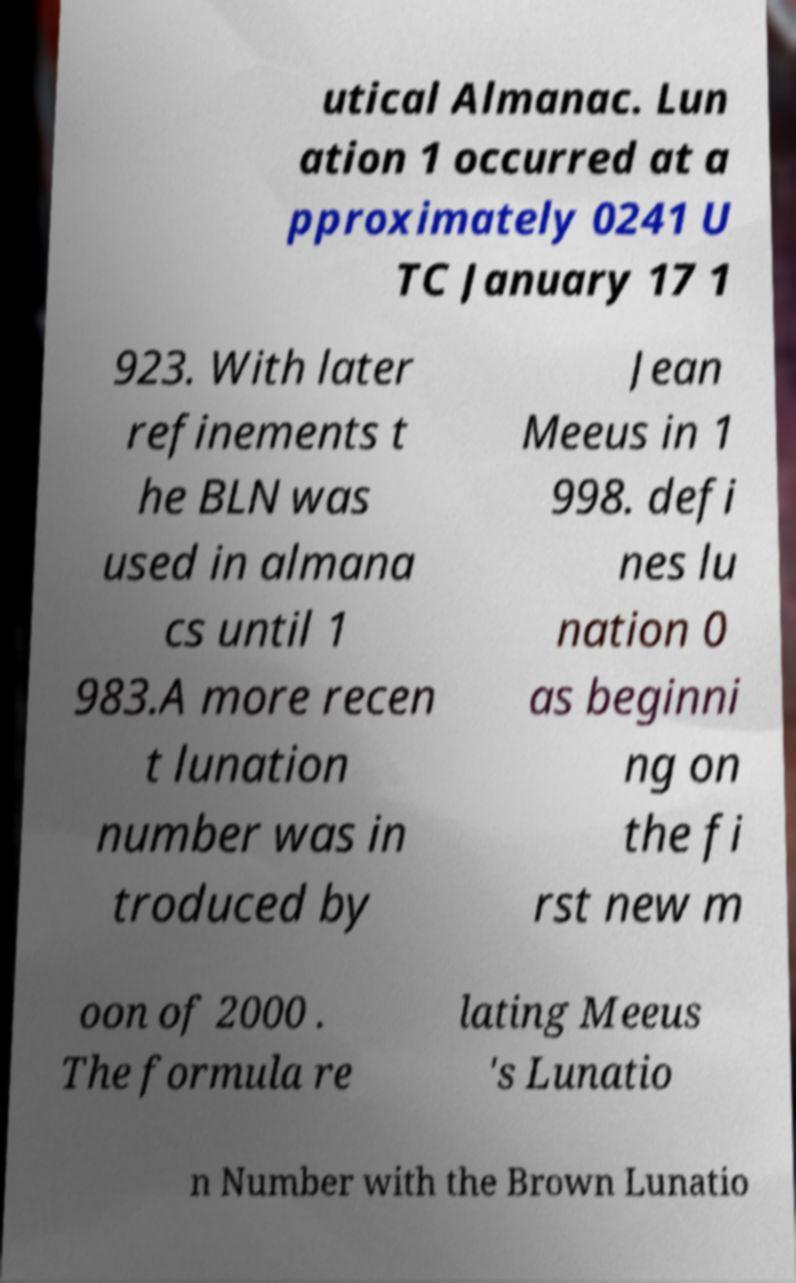What messages or text are displayed in this image? I need them in a readable, typed format. utical Almanac. Lun ation 1 occurred at a pproximately 0241 U TC January 17 1 923. With later refinements t he BLN was used in almana cs until 1 983.A more recen t lunation number was in troduced by Jean Meeus in 1 998. defi nes lu nation 0 as beginni ng on the fi rst new m oon of 2000 . The formula re lating Meeus 's Lunatio n Number with the Brown Lunatio 